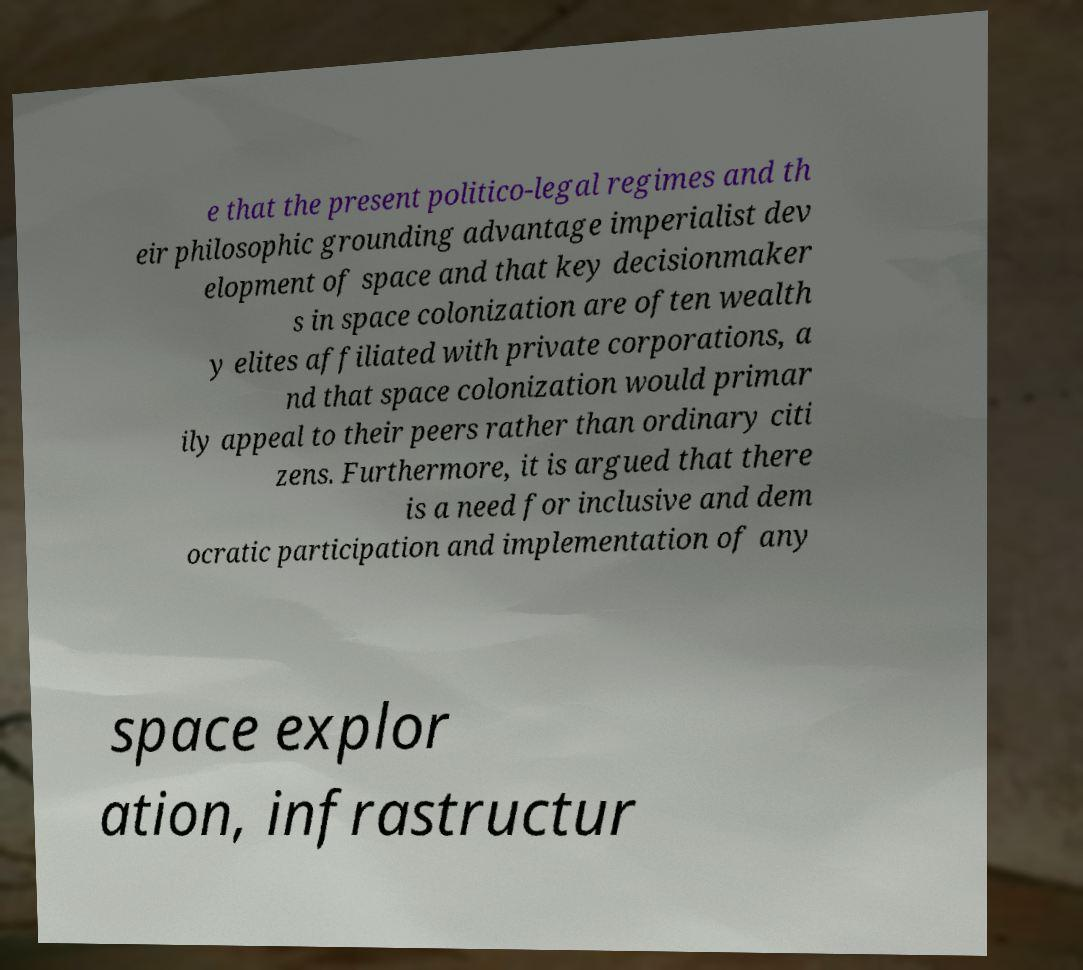Please read and relay the text visible in this image. What does it say? e that the present politico-legal regimes and th eir philosophic grounding advantage imperialist dev elopment of space and that key decisionmaker s in space colonization are often wealth y elites affiliated with private corporations, a nd that space colonization would primar ily appeal to their peers rather than ordinary citi zens. Furthermore, it is argued that there is a need for inclusive and dem ocratic participation and implementation of any space explor ation, infrastructur 